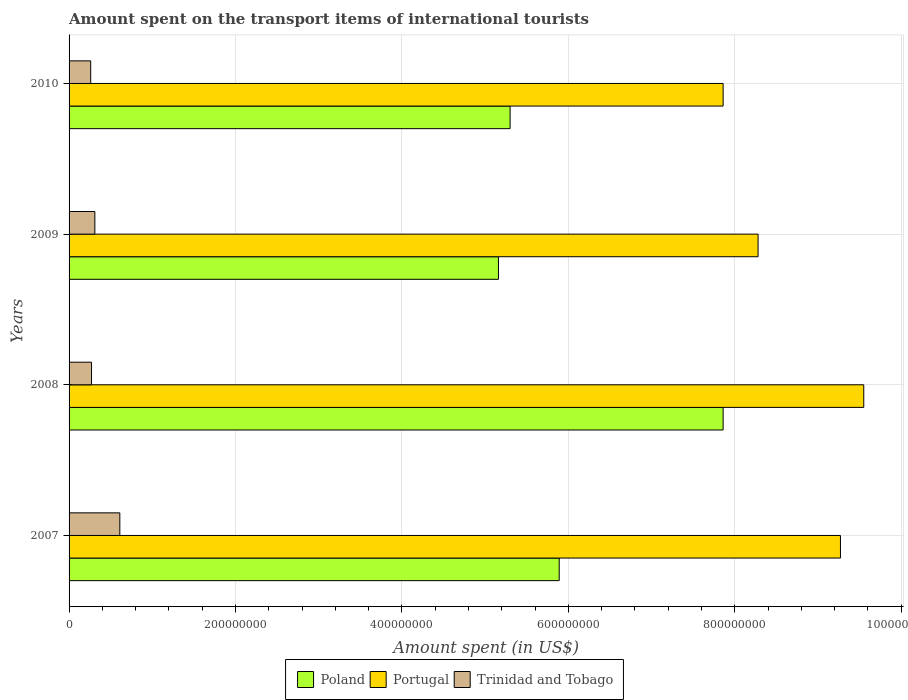How many different coloured bars are there?
Your answer should be very brief. 3. How many groups of bars are there?
Make the answer very short. 4. How many bars are there on the 1st tick from the bottom?
Your answer should be very brief. 3. In how many cases, is the number of bars for a given year not equal to the number of legend labels?
Your answer should be very brief. 0. What is the amount spent on the transport items of international tourists in Trinidad and Tobago in 2009?
Provide a short and direct response. 3.10e+07. Across all years, what is the maximum amount spent on the transport items of international tourists in Poland?
Make the answer very short. 7.86e+08. Across all years, what is the minimum amount spent on the transport items of international tourists in Trinidad and Tobago?
Keep it short and to the point. 2.60e+07. In which year was the amount spent on the transport items of international tourists in Poland maximum?
Give a very brief answer. 2008. In which year was the amount spent on the transport items of international tourists in Poland minimum?
Your response must be concise. 2009. What is the total amount spent on the transport items of international tourists in Poland in the graph?
Offer a very short reply. 2.42e+09. What is the difference between the amount spent on the transport items of international tourists in Trinidad and Tobago in 2007 and that in 2008?
Ensure brevity in your answer.  3.40e+07. What is the difference between the amount spent on the transport items of international tourists in Poland in 2008 and the amount spent on the transport items of international tourists in Portugal in 2007?
Your answer should be compact. -1.41e+08. What is the average amount spent on the transport items of international tourists in Trinidad and Tobago per year?
Your answer should be compact. 3.62e+07. In the year 2007, what is the difference between the amount spent on the transport items of international tourists in Poland and amount spent on the transport items of international tourists in Portugal?
Offer a terse response. -3.38e+08. What is the ratio of the amount spent on the transport items of international tourists in Trinidad and Tobago in 2008 to that in 2010?
Ensure brevity in your answer.  1.04. Is the amount spent on the transport items of international tourists in Trinidad and Tobago in 2007 less than that in 2008?
Provide a short and direct response. No. What is the difference between the highest and the second highest amount spent on the transport items of international tourists in Trinidad and Tobago?
Your answer should be very brief. 3.00e+07. What is the difference between the highest and the lowest amount spent on the transport items of international tourists in Portugal?
Offer a terse response. 1.69e+08. Is the sum of the amount spent on the transport items of international tourists in Trinidad and Tobago in 2007 and 2009 greater than the maximum amount spent on the transport items of international tourists in Portugal across all years?
Your answer should be compact. No. What does the 2nd bar from the top in 2008 represents?
Provide a succinct answer. Portugal. Are all the bars in the graph horizontal?
Offer a terse response. Yes. What is the difference between two consecutive major ticks on the X-axis?
Give a very brief answer. 2.00e+08. Does the graph contain any zero values?
Your answer should be very brief. No. Where does the legend appear in the graph?
Your answer should be very brief. Bottom center. How many legend labels are there?
Provide a short and direct response. 3. What is the title of the graph?
Ensure brevity in your answer.  Amount spent on the transport items of international tourists. What is the label or title of the X-axis?
Your response must be concise. Amount spent (in US$). What is the label or title of the Y-axis?
Offer a terse response. Years. What is the Amount spent (in US$) of Poland in 2007?
Ensure brevity in your answer.  5.89e+08. What is the Amount spent (in US$) in Portugal in 2007?
Your answer should be compact. 9.27e+08. What is the Amount spent (in US$) of Trinidad and Tobago in 2007?
Your response must be concise. 6.10e+07. What is the Amount spent (in US$) in Poland in 2008?
Provide a succinct answer. 7.86e+08. What is the Amount spent (in US$) of Portugal in 2008?
Offer a very short reply. 9.55e+08. What is the Amount spent (in US$) in Trinidad and Tobago in 2008?
Keep it short and to the point. 2.70e+07. What is the Amount spent (in US$) of Poland in 2009?
Provide a short and direct response. 5.16e+08. What is the Amount spent (in US$) in Portugal in 2009?
Offer a terse response. 8.28e+08. What is the Amount spent (in US$) in Trinidad and Tobago in 2009?
Provide a short and direct response. 3.10e+07. What is the Amount spent (in US$) of Poland in 2010?
Provide a short and direct response. 5.30e+08. What is the Amount spent (in US$) in Portugal in 2010?
Your response must be concise. 7.86e+08. What is the Amount spent (in US$) of Trinidad and Tobago in 2010?
Offer a terse response. 2.60e+07. Across all years, what is the maximum Amount spent (in US$) in Poland?
Your answer should be compact. 7.86e+08. Across all years, what is the maximum Amount spent (in US$) in Portugal?
Your answer should be very brief. 9.55e+08. Across all years, what is the maximum Amount spent (in US$) in Trinidad and Tobago?
Give a very brief answer. 6.10e+07. Across all years, what is the minimum Amount spent (in US$) in Poland?
Provide a succinct answer. 5.16e+08. Across all years, what is the minimum Amount spent (in US$) in Portugal?
Offer a terse response. 7.86e+08. Across all years, what is the minimum Amount spent (in US$) of Trinidad and Tobago?
Your answer should be very brief. 2.60e+07. What is the total Amount spent (in US$) in Poland in the graph?
Make the answer very short. 2.42e+09. What is the total Amount spent (in US$) in Portugal in the graph?
Provide a short and direct response. 3.50e+09. What is the total Amount spent (in US$) in Trinidad and Tobago in the graph?
Provide a succinct answer. 1.45e+08. What is the difference between the Amount spent (in US$) in Poland in 2007 and that in 2008?
Offer a terse response. -1.97e+08. What is the difference between the Amount spent (in US$) of Portugal in 2007 and that in 2008?
Make the answer very short. -2.80e+07. What is the difference between the Amount spent (in US$) of Trinidad and Tobago in 2007 and that in 2008?
Your answer should be very brief. 3.40e+07. What is the difference between the Amount spent (in US$) in Poland in 2007 and that in 2009?
Provide a succinct answer. 7.30e+07. What is the difference between the Amount spent (in US$) of Portugal in 2007 and that in 2009?
Ensure brevity in your answer.  9.90e+07. What is the difference between the Amount spent (in US$) of Trinidad and Tobago in 2007 and that in 2009?
Your answer should be compact. 3.00e+07. What is the difference between the Amount spent (in US$) in Poland in 2007 and that in 2010?
Provide a succinct answer. 5.90e+07. What is the difference between the Amount spent (in US$) in Portugal in 2007 and that in 2010?
Make the answer very short. 1.41e+08. What is the difference between the Amount spent (in US$) in Trinidad and Tobago in 2007 and that in 2010?
Make the answer very short. 3.50e+07. What is the difference between the Amount spent (in US$) in Poland in 2008 and that in 2009?
Your response must be concise. 2.70e+08. What is the difference between the Amount spent (in US$) of Portugal in 2008 and that in 2009?
Give a very brief answer. 1.27e+08. What is the difference between the Amount spent (in US$) of Trinidad and Tobago in 2008 and that in 2009?
Provide a short and direct response. -4.00e+06. What is the difference between the Amount spent (in US$) of Poland in 2008 and that in 2010?
Keep it short and to the point. 2.56e+08. What is the difference between the Amount spent (in US$) of Portugal in 2008 and that in 2010?
Offer a very short reply. 1.69e+08. What is the difference between the Amount spent (in US$) of Trinidad and Tobago in 2008 and that in 2010?
Offer a very short reply. 1.00e+06. What is the difference between the Amount spent (in US$) in Poland in 2009 and that in 2010?
Make the answer very short. -1.40e+07. What is the difference between the Amount spent (in US$) of Portugal in 2009 and that in 2010?
Offer a terse response. 4.20e+07. What is the difference between the Amount spent (in US$) of Trinidad and Tobago in 2009 and that in 2010?
Your answer should be very brief. 5.00e+06. What is the difference between the Amount spent (in US$) of Poland in 2007 and the Amount spent (in US$) of Portugal in 2008?
Offer a terse response. -3.66e+08. What is the difference between the Amount spent (in US$) of Poland in 2007 and the Amount spent (in US$) of Trinidad and Tobago in 2008?
Ensure brevity in your answer.  5.62e+08. What is the difference between the Amount spent (in US$) in Portugal in 2007 and the Amount spent (in US$) in Trinidad and Tobago in 2008?
Your response must be concise. 9.00e+08. What is the difference between the Amount spent (in US$) of Poland in 2007 and the Amount spent (in US$) of Portugal in 2009?
Your answer should be very brief. -2.39e+08. What is the difference between the Amount spent (in US$) of Poland in 2007 and the Amount spent (in US$) of Trinidad and Tobago in 2009?
Ensure brevity in your answer.  5.58e+08. What is the difference between the Amount spent (in US$) in Portugal in 2007 and the Amount spent (in US$) in Trinidad and Tobago in 2009?
Offer a very short reply. 8.96e+08. What is the difference between the Amount spent (in US$) of Poland in 2007 and the Amount spent (in US$) of Portugal in 2010?
Your answer should be very brief. -1.97e+08. What is the difference between the Amount spent (in US$) in Poland in 2007 and the Amount spent (in US$) in Trinidad and Tobago in 2010?
Ensure brevity in your answer.  5.63e+08. What is the difference between the Amount spent (in US$) of Portugal in 2007 and the Amount spent (in US$) of Trinidad and Tobago in 2010?
Provide a succinct answer. 9.01e+08. What is the difference between the Amount spent (in US$) of Poland in 2008 and the Amount spent (in US$) of Portugal in 2009?
Offer a very short reply. -4.20e+07. What is the difference between the Amount spent (in US$) of Poland in 2008 and the Amount spent (in US$) of Trinidad and Tobago in 2009?
Your response must be concise. 7.55e+08. What is the difference between the Amount spent (in US$) of Portugal in 2008 and the Amount spent (in US$) of Trinidad and Tobago in 2009?
Make the answer very short. 9.24e+08. What is the difference between the Amount spent (in US$) in Poland in 2008 and the Amount spent (in US$) in Trinidad and Tobago in 2010?
Offer a terse response. 7.60e+08. What is the difference between the Amount spent (in US$) in Portugal in 2008 and the Amount spent (in US$) in Trinidad and Tobago in 2010?
Provide a succinct answer. 9.29e+08. What is the difference between the Amount spent (in US$) of Poland in 2009 and the Amount spent (in US$) of Portugal in 2010?
Your response must be concise. -2.70e+08. What is the difference between the Amount spent (in US$) in Poland in 2009 and the Amount spent (in US$) in Trinidad and Tobago in 2010?
Your response must be concise. 4.90e+08. What is the difference between the Amount spent (in US$) of Portugal in 2009 and the Amount spent (in US$) of Trinidad and Tobago in 2010?
Give a very brief answer. 8.02e+08. What is the average Amount spent (in US$) of Poland per year?
Offer a terse response. 6.05e+08. What is the average Amount spent (in US$) in Portugal per year?
Ensure brevity in your answer.  8.74e+08. What is the average Amount spent (in US$) in Trinidad and Tobago per year?
Keep it short and to the point. 3.62e+07. In the year 2007, what is the difference between the Amount spent (in US$) in Poland and Amount spent (in US$) in Portugal?
Give a very brief answer. -3.38e+08. In the year 2007, what is the difference between the Amount spent (in US$) of Poland and Amount spent (in US$) of Trinidad and Tobago?
Your answer should be compact. 5.28e+08. In the year 2007, what is the difference between the Amount spent (in US$) of Portugal and Amount spent (in US$) of Trinidad and Tobago?
Provide a short and direct response. 8.66e+08. In the year 2008, what is the difference between the Amount spent (in US$) of Poland and Amount spent (in US$) of Portugal?
Provide a short and direct response. -1.69e+08. In the year 2008, what is the difference between the Amount spent (in US$) of Poland and Amount spent (in US$) of Trinidad and Tobago?
Your answer should be compact. 7.59e+08. In the year 2008, what is the difference between the Amount spent (in US$) in Portugal and Amount spent (in US$) in Trinidad and Tobago?
Your answer should be very brief. 9.28e+08. In the year 2009, what is the difference between the Amount spent (in US$) of Poland and Amount spent (in US$) of Portugal?
Your answer should be compact. -3.12e+08. In the year 2009, what is the difference between the Amount spent (in US$) of Poland and Amount spent (in US$) of Trinidad and Tobago?
Provide a succinct answer. 4.85e+08. In the year 2009, what is the difference between the Amount spent (in US$) of Portugal and Amount spent (in US$) of Trinidad and Tobago?
Offer a terse response. 7.97e+08. In the year 2010, what is the difference between the Amount spent (in US$) of Poland and Amount spent (in US$) of Portugal?
Ensure brevity in your answer.  -2.56e+08. In the year 2010, what is the difference between the Amount spent (in US$) of Poland and Amount spent (in US$) of Trinidad and Tobago?
Provide a succinct answer. 5.04e+08. In the year 2010, what is the difference between the Amount spent (in US$) in Portugal and Amount spent (in US$) in Trinidad and Tobago?
Ensure brevity in your answer.  7.60e+08. What is the ratio of the Amount spent (in US$) in Poland in 2007 to that in 2008?
Provide a succinct answer. 0.75. What is the ratio of the Amount spent (in US$) of Portugal in 2007 to that in 2008?
Your answer should be very brief. 0.97. What is the ratio of the Amount spent (in US$) of Trinidad and Tobago in 2007 to that in 2008?
Keep it short and to the point. 2.26. What is the ratio of the Amount spent (in US$) of Poland in 2007 to that in 2009?
Your response must be concise. 1.14. What is the ratio of the Amount spent (in US$) of Portugal in 2007 to that in 2009?
Ensure brevity in your answer.  1.12. What is the ratio of the Amount spent (in US$) in Trinidad and Tobago in 2007 to that in 2009?
Offer a terse response. 1.97. What is the ratio of the Amount spent (in US$) in Poland in 2007 to that in 2010?
Keep it short and to the point. 1.11. What is the ratio of the Amount spent (in US$) in Portugal in 2007 to that in 2010?
Keep it short and to the point. 1.18. What is the ratio of the Amount spent (in US$) in Trinidad and Tobago in 2007 to that in 2010?
Your response must be concise. 2.35. What is the ratio of the Amount spent (in US$) of Poland in 2008 to that in 2009?
Provide a short and direct response. 1.52. What is the ratio of the Amount spent (in US$) of Portugal in 2008 to that in 2009?
Ensure brevity in your answer.  1.15. What is the ratio of the Amount spent (in US$) of Trinidad and Tobago in 2008 to that in 2009?
Your answer should be compact. 0.87. What is the ratio of the Amount spent (in US$) of Poland in 2008 to that in 2010?
Make the answer very short. 1.48. What is the ratio of the Amount spent (in US$) of Portugal in 2008 to that in 2010?
Your response must be concise. 1.22. What is the ratio of the Amount spent (in US$) in Poland in 2009 to that in 2010?
Your answer should be compact. 0.97. What is the ratio of the Amount spent (in US$) in Portugal in 2009 to that in 2010?
Your response must be concise. 1.05. What is the ratio of the Amount spent (in US$) in Trinidad and Tobago in 2009 to that in 2010?
Make the answer very short. 1.19. What is the difference between the highest and the second highest Amount spent (in US$) in Poland?
Provide a succinct answer. 1.97e+08. What is the difference between the highest and the second highest Amount spent (in US$) of Portugal?
Offer a very short reply. 2.80e+07. What is the difference between the highest and the second highest Amount spent (in US$) in Trinidad and Tobago?
Give a very brief answer. 3.00e+07. What is the difference between the highest and the lowest Amount spent (in US$) of Poland?
Provide a short and direct response. 2.70e+08. What is the difference between the highest and the lowest Amount spent (in US$) in Portugal?
Offer a very short reply. 1.69e+08. What is the difference between the highest and the lowest Amount spent (in US$) of Trinidad and Tobago?
Give a very brief answer. 3.50e+07. 